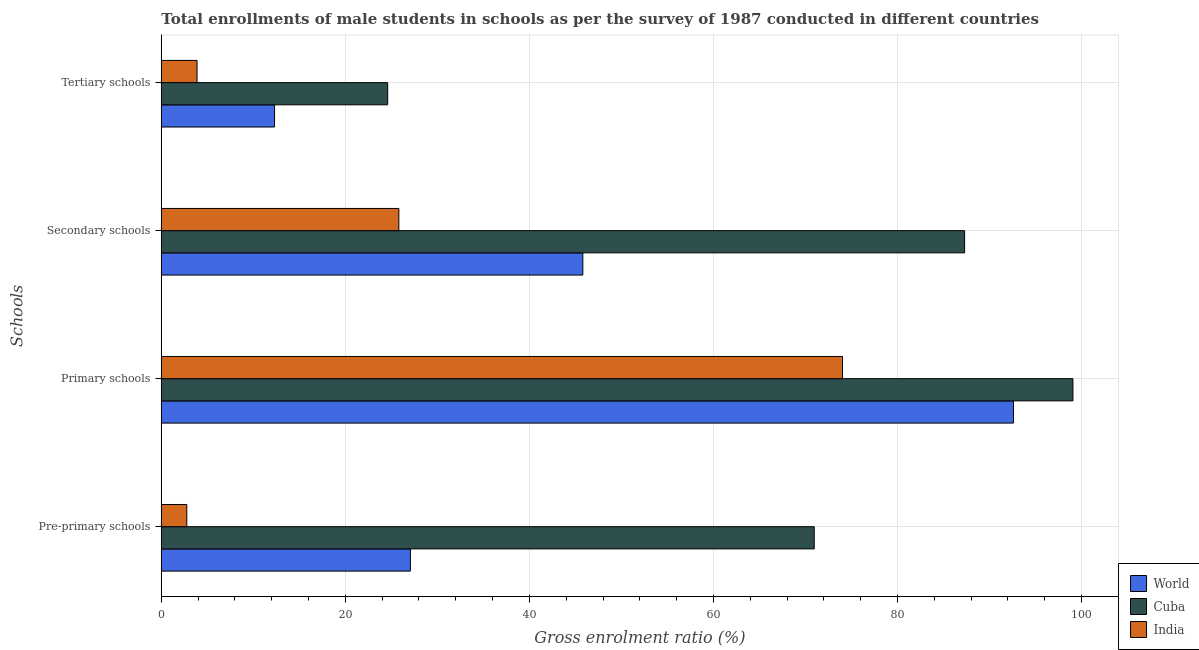Are the number of bars per tick equal to the number of legend labels?
Your response must be concise. Yes. Are the number of bars on each tick of the Y-axis equal?
Your answer should be compact. Yes. How many bars are there on the 2nd tick from the top?
Your answer should be compact. 3. What is the label of the 1st group of bars from the top?
Provide a short and direct response. Tertiary schools. What is the gross enrolment ratio(male) in tertiary schools in World?
Your response must be concise. 12.3. Across all countries, what is the maximum gross enrolment ratio(male) in secondary schools?
Provide a short and direct response. 87.3. Across all countries, what is the minimum gross enrolment ratio(male) in pre-primary schools?
Your answer should be very brief. 2.77. In which country was the gross enrolment ratio(male) in secondary schools maximum?
Provide a succinct answer. Cuba. What is the total gross enrolment ratio(male) in primary schools in the graph?
Ensure brevity in your answer.  265.71. What is the difference between the gross enrolment ratio(male) in pre-primary schools in World and that in Cuba?
Your answer should be compact. -43.89. What is the difference between the gross enrolment ratio(male) in pre-primary schools in Cuba and the gross enrolment ratio(male) in secondary schools in World?
Offer a terse response. 25.15. What is the average gross enrolment ratio(male) in primary schools per country?
Your answer should be compact. 88.57. What is the difference between the gross enrolment ratio(male) in tertiary schools and gross enrolment ratio(male) in primary schools in India?
Your response must be concise. -70.15. In how many countries, is the gross enrolment ratio(male) in tertiary schools greater than 28 %?
Provide a succinct answer. 0. What is the ratio of the gross enrolment ratio(male) in secondary schools in World to that in Cuba?
Make the answer very short. 0.52. Is the difference between the gross enrolment ratio(male) in primary schools in Cuba and India greater than the difference between the gross enrolment ratio(male) in pre-primary schools in Cuba and India?
Provide a short and direct response. No. What is the difference between the highest and the second highest gross enrolment ratio(male) in tertiary schools?
Offer a terse response. 12.3. What is the difference between the highest and the lowest gross enrolment ratio(male) in tertiary schools?
Provide a short and direct response. 20.72. In how many countries, is the gross enrolment ratio(male) in pre-primary schools greater than the average gross enrolment ratio(male) in pre-primary schools taken over all countries?
Make the answer very short. 1. Is the sum of the gross enrolment ratio(male) in pre-primary schools in World and India greater than the maximum gross enrolment ratio(male) in tertiary schools across all countries?
Offer a very short reply. Yes. What does the 1st bar from the bottom in Secondary schools represents?
Your answer should be compact. World. How many countries are there in the graph?
Keep it short and to the point. 3. What is the difference between two consecutive major ticks on the X-axis?
Provide a succinct answer. 20. Does the graph contain any zero values?
Offer a terse response. No. Where does the legend appear in the graph?
Offer a very short reply. Bottom right. What is the title of the graph?
Keep it short and to the point. Total enrollments of male students in schools as per the survey of 1987 conducted in different countries. Does "South Sudan" appear as one of the legend labels in the graph?
Ensure brevity in your answer.  No. What is the label or title of the Y-axis?
Offer a terse response. Schools. What is the Gross enrolment ratio (%) in World in Pre-primary schools?
Your answer should be very brief. 27.07. What is the Gross enrolment ratio (%) in Cuba in Pre-primary schools?
Give a very brief answer. 70.95. What is the Gross enrolment ratio (%) of India in Pre-primary schools?
Offer a terse response. 2.77. What is the Gross enrolment ratio (%) of World in Primary schools?
Provide a short and direct response. 92.61. What is the Gross enrolment ratio (%) in Cuba in Primary schools?
Offer a very short reply. 99.07. What is the Gross enrolment ratio (%) in India in Primary schools?
Offer a terse response. 74.03. What is the Gross enrolment ratio (%) in World in Secondary schools?
Ensure brevity in your answer.  45.81. What is the Gross enrolment ratio (%) in Cuba in Secondary schools?
Give a very brief answer. 87.3. What is the Gross enrolment ratio (%) in India in Secondary schools?
Your response must be concise. 25.81. What is the Gross enrolment ratio (%) in World in Tertiary schools?
Give a very brief answer. 12.3. What is the Gross enrolment ratio (%) in Cuba in Tertiary schools?
Offer a terse response. 24.6. What is the Gross enrolment ratio (%) in India in Tertiary schools?
Your response must be concise. 3.88. Across all Schools, what is the maximum Gross enrolment ratio (%) of World?
Offer a terse response. 92.61. Across all Schools, what is the maximum Gross enrolment ratio (%) of Cuba?
Ensure brevity in your answer.  99.07. Across all Schools, what is the maximum Gross enrolment ratio (%) in India?
Offer a terse response. 74.03. Across all Schools, what is the minimum Gross enrolment ratio (%) in World?
Offer a very short reply. 12.3. Across all Schools, what is the minimum Gross enrolment ratio (%) in Cuba?
Keep it short and to the point. 24.6. Across all Schools, what is the minimum Gross enrolment ratio (%) in India?
Make the answer very short. 2.77. What is the total Gross enrolment ratio (%) of World in the graph?
Offer a very short reply. 177.79. What is the total Gross enrolment ratio (%) in Cuba in the graph?
Keep it short and to the point. 281.92. What is the total Gross enrolment ratio (%) of India in the graph?
Provide a short and direct response. 106.5. What is the difference between the Gross enrolment ratio (%) of World in Pre-primary schools and that in Primary schools?
Ensure brevity in your answer.  -65.54. What is the difference between the Gross enrolment ratio (%) in Cuba in Pre-primary schools and that in Primary schools?
Provide a succinct answer. -28.11. What is the difference between the Gross enrolment ratio (%) in India in Pre-primary schools and that in Primary schools?
Your answer should be very brief. -71.26. What is the difference between the Gross enrolment ratio (%) of World in Pre-primary schools and that in Secondary schools?
Your answer should be compact. -18.74. What is the difference between the Gross enrolment ratio (%) of Cuba in Pre-primary schools and that in Secondary schools?
Your answer should be very brief. -16.34. What is the difference between the Gross enrolment ratio (%) of India in Pre-primary schools and that in Secondary schools?
Keep it short and to the point. -23.04. What is the difference between the Gross enrolment ratio (%) of World in Pre-primary schools and that in Tertiary schools?
Give a very brief answer. 14.77. What is the difference between the Gross enrolment ratio (%) of Cuba in Pre-primary schools and that in Tertiary schools?
Keep it short and to the point. 46.35. What is the difference between the Gross enrolment ratio (%) of India in Pre-primary schools and that in Tertiary schools?
Give a very brief answer. -1.11. What is the difference between the Gross enrolment ratio (%) of World in Primary schools and that in Secondary schools?
Your response must be concise. 46.8. What is the difference between the Gross enrolment ratio (%) of Cuba in Primary schools and that in Secondary schools?
Give a very brief answer. 11.77. What is the difference between the Gross enrolment ratio (%) of India in Primary schools and that in Secondary schools?
Provide a succinct answer. 48.22. What is the difference between the Gross enrolment ratio (%) in World in Primary schools and that in Tertiary schools?
Give a very brief answer. 80.3. What is the difference between the Gross enrolment ratio (%) in Cuba in Primary schools and that in Tertiary schools?
Your answer should be very brief. 74.47. What is the difference between the Gross enrolment ratio (%) in India in Primary schools and that in Tertiary schools?
Provide a short and direct response. 70.15. What is the difference between the Gross enrolment ratio (%) in World in Secondary schools and that in Tertiary schools?
Ensure brevity in your answer.  33.5. What is the difference between the Gross enrolment ratio (%) of Cuba in Secondary schools and that in Tertiary schools?
Offer a very short reply. 62.7. What is the difference between the Gross enrolment ratio (%) in India in Secondary schools and that in Tertiary schools?
Provide a succinct answer. 21.93. What is the difference between the Gross enrolment ratio (%) of World in Pre-primary schools and the Gross enrolment ratio (%) of Cuba in Primary schools?
Your answer should be very brief. -72. What is the difference between the Gross enrolment ratio (%) in World in Pre-primary schools and the Gross enrolment ratio (%) in India in Primary schools?
Your response must be concise. -46.96. What is the difference between the Gross enrolment ratio (%) of Cuba in Pre-primary schools and the Gross enrolment ratio (%) of India in Primary schools?
Offer a very short reply. -3.08. What is the difference between the Gross enrolment ratio (%) of World in Pre-primary schools and the Gross enrolment ratio (%) of Cuba in Secondary schools?
Your response must be concise. -60.23. What is the difference between the Gross enrolment ratio (%) in World in Pre-primary schools and the Gross enrolment ratio (%) in India in Secondary schools?
Your response must be concise. 1.26. What is the difference between the Gross enrolment ratio (%) of Cuba in Pre-primary schools and the Gross enrolment ratio (%) of India in Secondary schools?
Offer a very short reply. 45.14. What is the difference between the Gross enrolment ratio (%) in World in Pre-primary schools and the Gross enrolment ratio (%) in Cuba in Tertiary schools?
Give a very brief answer. 2.47. What is the difference between the Gross enrolment ratio (%) of World in Pre-primary schools and the Gross enrolment ratio (%) of India in Tertiary schools?
Offer a very short reply. 23.19. What is the difference between the Gross enrolment ratio (%) in Cuba in Pre-primary schools and the Gross enrolment ratio (%) in India in Tertiary schools?
Make the answer very short. 67.07. What is the difference between the Gross enrolment ratio (%) of World in Primary schools and the Gross enrolment ratio (%) of Cuba in Secondary schools?
Provide a short and direct response. 5.31. What is the difference between the Gross enrolment ratio (%) in World in Primary schools and the Gross enrolment ratio (%) in India in Secondary schools?
Provide a short and direct response. 66.79. What is the difference between the Gross enrolment ratio (%) of Cuba in Primary schools and the Gross enrolment ratio (%) of India in Secondary schools?
Your answer should be very brief. 73.26. What is the difference between the Gross enrolment ratio (%) of World in Primary schools and the Gross enrolment ratio (%) of Cuba in Tertiary schools?
Your answer should be compact. 68.01. What is the difference between the Gross enrolment ratio (%) in World in Primary schools and the Gross enrolment ratio (%) in India in Tertiary schools?
Keep it short and to the point. 88.72. What is the difference between the Gross enrolment ratio (%) in Cuba in Primary schools and the Gross enrolment ratio (%) in India in Tertiary schools?
Your response must be concise. 95.19. What is the difference between the Gross enrolment ratio (%) of World in Secondary schools and the Gross enrolment ratio (%) of Cuba in Tertiary schools?
Offer a very short reply. 21.21. What is the difference between the Gross enrolment ratio (%) in World in Secondary schools and the Gross enrolment ratio (%) in India in Tertiary schools?
Offer a terse response. 41.92. What is the difference between the Gross enrolment ratio (%) in Cuba in Secondary schools and the Gross enrolment ratio (%) in India in Tertiary schools?
Provide a short and direct response. 83.41. What is the average Gross enrolment ratio (%) of World per Schools?
Provide a short and direct response. 44.45. What is the average Gross enrolment ratio (%) of Cuba per Schools?
Give a very brief answer. 70.48. What is the average Gross enrolment ratio (%) of India per Schools?
Offer a terse response. 26.62. What is the difference between the Gross enrolment ratio (%) in World and Gross enrolment ratio (%) in Cuba in Pre-primary schools?
Keep it short and to the point. -43.89. What is the difference between the Gross enrolment ratio (%) of World and Gross enrolment ratio (%) of India in Pre-primary schools?
Provide a short and direct response. 24.3. What is the difference between the Gross enrolment ratio (%) of Cuba and Gross enrolment ratio (%) of India in Pre-primary schools?
Provide a short and direct response. 68.19. What is the difference between the Gross enrolment ratio (%) in World and Gross enrolment ratio (%) in Cuba in Primary schools?
Give a very brief answer. -6.46. What is the difference between the Gross enrolment ratio (%) in World and Gross enrolment ratio (%) in India in Primary schools?
Make the answer very short. 18.58. What is the difference between the Gross enrolment ratio (%) in Cuba and Gross enrolment ratio (%) in India in Primary schools?
Offer a very short reply. 25.04. What is the difference between the Gross enrolment ratio (%) in World and Gross enrolment ratio (%) in Cuba in Secondary schools?
Your answer should be compact. -41.49. What is the difference between the Gross enrolment ratio (%) in World and Gross enrolment ratio (%) in India in Secondary schools?
Offer a terse response. 20. What is the difference between the Gross enrolment ratio (%) in Cuba and Gross enrolment ratio (%) in India in Secondary schools?
Provide a succinct answer. 61.48. What is the difference between the Gross enrolment ratio (%) in World and Gross enrolment ratio (%) in Cuba in Tertiary schools?
Provide a short and direct response. -12.3. What is the difference between the Gross enrolment ratio (%) of World and Gross enrolment ratio (%) of India in Tertiary schools?
Provide a succinct answer. 8.42. What is the difference between the Gross enrolment ratio (%) of Cuba and Gross enrolment ratio (%) of India in Tertiary schools?
Your answer should be very brief. 20.72. What is the ratio of the Gross enrolment ratio (%) in World in Pre-primary schools to that in Primary schools?
Give a very brief answer. 0.29. What is the ratio of the Gross enrolment ratio (%) of Cuba in Pre-primary schools to that in Primary schools?
Make the answer very short. 0.72. What is the ratio of the Gross enrolment ratio (%) in India in Pre-primary schools to that in Primary schools?
Offer a very short reply. 0.04. What is the ratio of the Gross enrolment ratio (%) of World in Pre-primary schools to that in Secondary schools?
Provide a succinct answer. 0.59. What is the ratio of the Gross enrolment ratio (%) of Cuba in Pre-primary schools to that in Secondary schools?
Offer a very short reply. 0.81. What is the ratio of the Gross enrolment ratio (%) of India in Pre-primary schools to that in Secondary schools?
Offer a very short reply. 0.11. What is the ratio of the Gross enrolment ratio (%) in World in Pre-primary schools to that in Tertiary schools?
Your answer should be very brief. 2.2. What is the ratio of the Gross enrolment ratio (%) in Cuba in Pre-primary schools to that in Tertiary schools?
Keep it short and to the point. 2.88. What is the ratio of the Gross enrolment ratio (%) of India in Pre-primary schools to that in Tertiary schools?
Your response must be concise. 0.71. What is the ratio of the Gross enrolment ratio (%) in World in Primary schools to that in Secondary schools?
Provide a succinct answer. 2.02. What is the ratio of the Gross enrolment ratio (%) of Cuba in Primary schools to that in Secondary schools?
Your answer should be compact. 1.13. What is the ratio of the Gross enrolment ratio (%) of India in Primary schools to that in Secondary schools?
Give a very brief answer. 2.87. What is the ratio of the Gross enrolment ratio (%) in World in Primary schools to that in Tertiary schools?
Your response must be concise. 7.53. What is the ratio of the Gross enrolment ratio (%) of Cuba in Primary schools to that in Tertiary schools?
Ensure brevity in your answer.  4.03. What is the ratio of the Gross enrolment ratio (%) in India in Primary schools to that in Tertiary schools?
Your answer should be very brief. 19.06. What is the ratio of the Gross enrolment ratio (%) in World in Secondary schools to that in Tertiary schools?
Make the answer very short. 3.72. What is the ratio of the Gross enrolment ratio (%) of Cuba in Secondary schools to that in Tertiary schools?
Offer a terse response. 3.55. What is the ratio of the Gross enrolment ratio (%) in India in Secondary schools to that in Tertiary schools?
Provide a short and direct response. 6.65. What is the difference between the highest and the second highest Gross enrolment ratio (%) in World?
Offer a terse response. 46.8. What is the difference between the highest and the second highest Gross enrolment ratio (%) in Cuba?
Keep it short and to the point. 11.77. What is the difference between the highest and the second highest Gross enrolment ratio (%) of India?
Make the answer very short. 48.22. What is the difference between the highest and the lowest Gross enrolment ratio (%) in World?
Offer a very short reply. 80.3. What is the difference between the highest and the lowest Gross enrolment ratio (%) in Cuba?
Offer a terse response. 74.47. What is the difference between the highest and the lowest Gross enrolment ratio (%) in India?
Your answer should be compact. 71.26. 